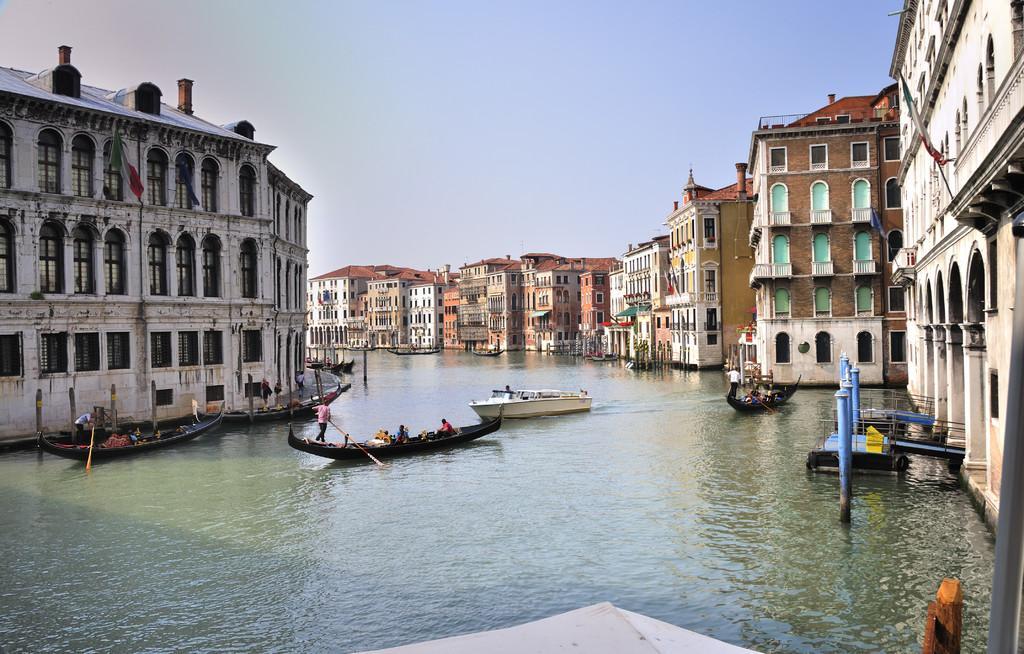In one or two sentences, can you explain what this image depicts? In this picture we can see a few people on the boats visible on the water. There are some people holding objects visible on the boats. We can see some objects on the water. There are buildings, flags on the poles, other objects and the sky. 